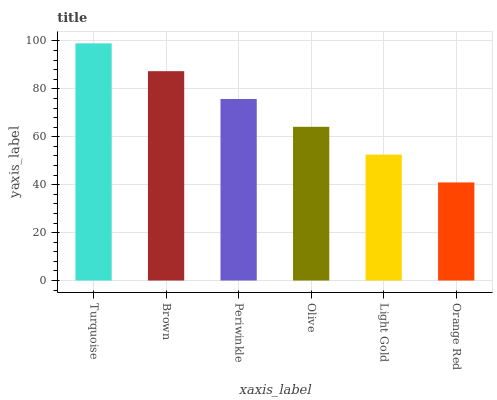Is Orange Red the minimum?
Answer yes or no. Yes. Is Turquoise the maximum?
Answer yes or no. Yes. Is Brown the minimum?
Answer yes or no. No. Is Brown the maximum?
Answer yes or no. No. Is Turquoise greater than Brown?
Answer yes or no. Yes. Is Brown less than Turquoise?
Answer yes or no. Yes. Is Brown greater than Turquoise?
Answer yes or no. No. Is Turquoise less than Brown?
Answer yes or no. No. Is Periwinkle the high median?
Answer yes or no. Yes. Is Olive the low median?
Answer yes or no. Yes. Is Brown the high median?
Answer yes or no. No. Is Brown the low median?
Answer yes or no. No. 